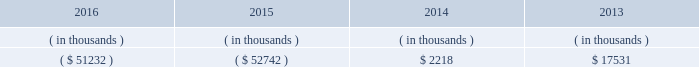Entergy arkansas , inc .
And subsidiaries management 2019s financial discussion and analysis stock restrict the amount of retained earnings available for the payment of cash dividends or other distributions on its common and preferred stock .
Sources of capital entergy arkansas 2019s sources to meet its capital requirements include : 2022 internally generated funds ; 2022 cash on hand ; 2022 debt or preferred stock issuances ; and 2022 bank financing under new or existing facilities .
Entergy arkansas may refinance , redeem , or otherwise retire debt and preferred stock prior to maturity , to the extent market conditions and interest and dividend rates are favorable .
All debt and common and preferred stock issuances by entergy arkansas require prior regulatory approval .
Preferred stock and debt issuances are also subject to issuance tests set forth in entergy arkansas 2019s corporate charters , bond indentures , and other agreements .
Entergy arkansas has sufficient capacity under these tests to meet its foreseeable capital needs .
Entergy arkansas 2019s receivables from or ( payables to ) the money pool were as follows as of december 31 for each of the following years. .
See note 4 to the financial statements for a description of the money pool .
Entergy arkansas has a credit facility in the amount of $ 150 million scheduled to expire in august 2021 .
Entergy arkansas also has a $ 20 million credit facility scheduled to expire in april 2017 .
The $ 150 million credit facility allows entergy arkansas to issue letters of credit against 50% ( 50 % ) of the borrowing capacity of the facility .
As of december 31 , 2016 , there were no cash borrowings and no letters of credit outstanding under the credit facilities .
In addition , entergy arkansas is a party to an uncommitted letter of credit facility as a means to post collateral to support its obligations under miso .
As of december 31 , 2016 , a $ 1 million letter of credit was outstanding under entergy arkansas 2019s uncommitted letter of credit facility .
See note 4 to the financial statements for additional discussion of the credit facilities .
The entergy arkansas nuclear fuel company variable interest entity has a credit facility in the amount of $ 80 million scheduled to expire in may 2019 .
As of december 31 , 2016 , no letters of credit were outstanding under the credit facility to support commercial paper issued by the entergy arkansas nuclear fuel company variable interest entity .
See note 4 to the financial statements for additional discussion of the nuclear fuel company variable interest entity credit facility .
Entergy arkansas obtained authorizations from the ferc through october 2017 for short-term borrowings not to exceed an aggregate amount of $ 250 million at any time outstanding and long-term borrowings by its nuclear fuel company variable interest entity .
See note 4 to the financial statements for further discussion of entergy arkansas 2019s short-term borrowing limits .
The long-term securities issuances of entergy arkansas are limited to amounts authorized by the apsc and the tennessee regulatory authority ; the current authorizations extend through december 2018. .
How is cash flow of entergy arkansas affected by the change in balance of money pool from 2015 to 2016? 
Computations: (51232 - 52742)
Answer: -1510.0. 